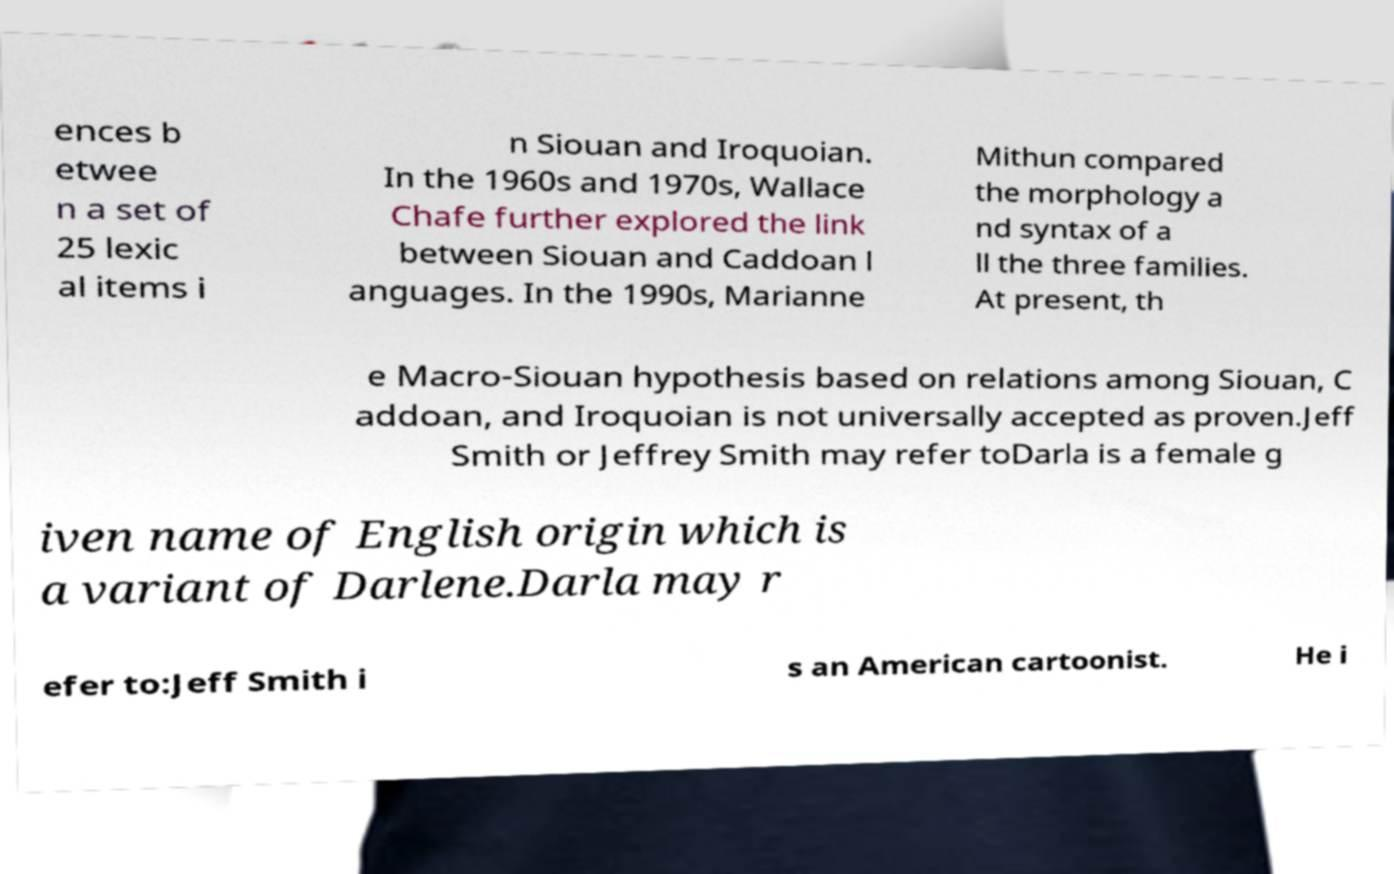Can you accurately transcribe the text from the provided image for me? ences b etwee n a set of 25 lexic al items i n Siouan and Iroquoian. In the 1960s and 1970s, Wallace Chafe further explored the link between Siouan and Caddoan l anguages. In the 1990s, Marianne Mithun compared the morphology a nd syntax of a ll the three families. At present, th e Macro-Siouan hypothesis based on relations among Siouan, C addoan, and Iroquoian is not universally accepted as proven.Jeff Smith or Jeffrey Smith may refer toDarla is a female g iven name of English origin which is a variant of Darlene.Darla may r efer to:Jeff Smith i s an American cartoonist. He i 